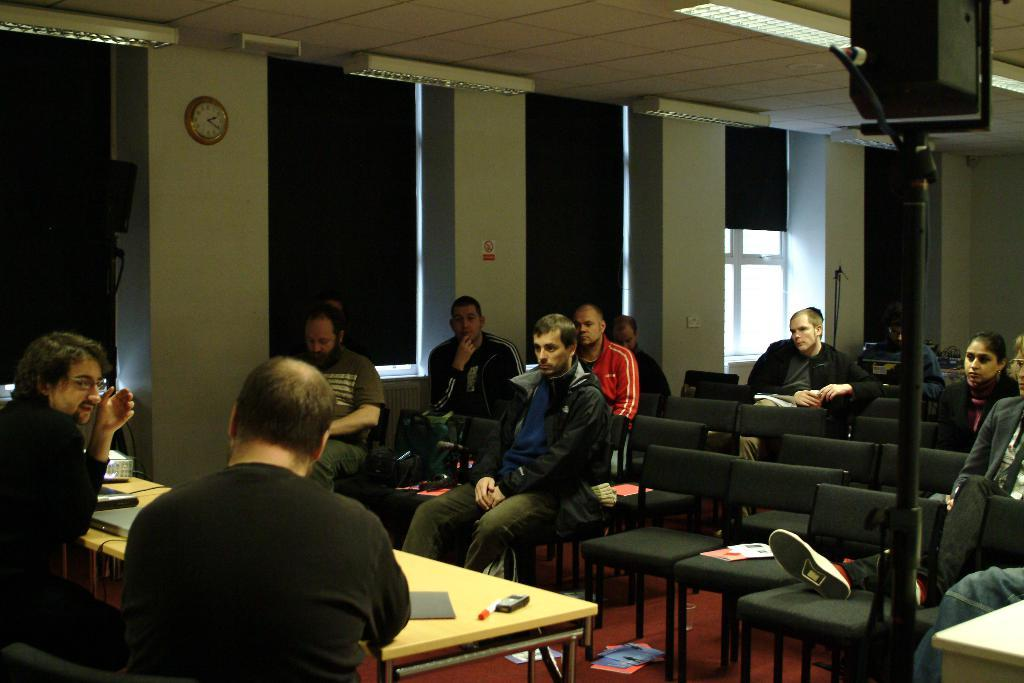What are the people in the image doing? There is a group of people sitting in chairs. What is on the table in the image? There is a marker, a paper, and a laptop on the table. Can you describe the background of the image? There is a speaker, a rod, a window, a clock, and a light in the background. What type of reward is the creature holding in the image? There is no creature present in the image, and therefore no reward can be observed. 